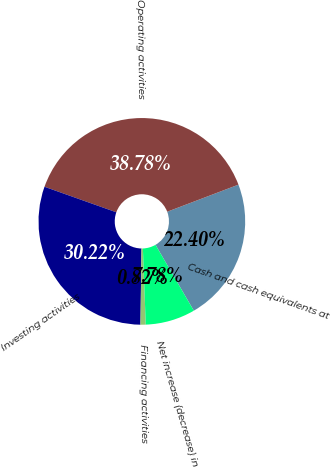<chart> <loc_0><loc_0><loc_500><loc_500><pie_chart><fcel>Cash and cash equivalents at<fcel>Operating activities<fcel>Investing activities<fcel>Financing activities<fcel>Net increase (decrease) in<nl><fcel>22.4%<fcel>38.78%<fcel>30.22%<fcel>0.82%<fcel>7.78%<nl></chart> 